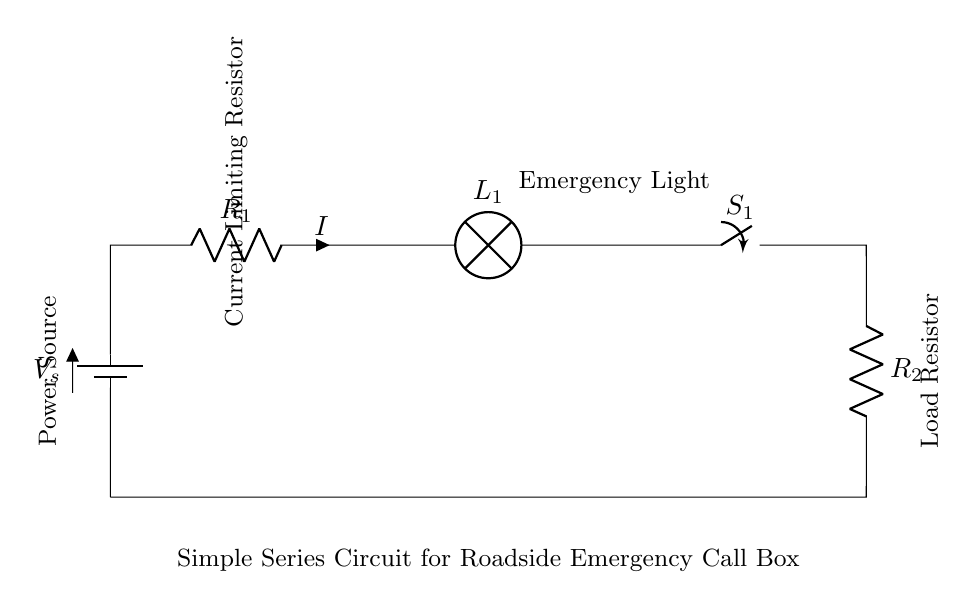What is the voltage source in this circuit? The voltage source in this circuit is represented by the symbol for the battery, indicating that there is a potential difference provided to the circuit.
Answer: V_s What type of light does this circuit use? The circuit includes a lamp, which is typically an emergency light in this context, indicating it will illuminate when the circuit is active.
Answer: Emergency Light How many resistors are present in this circuit? There are two resistors shown in the circuit, one labeled as R1 and the other as R2, which are both part of the series connection.
Answer: 2 What happens to the current if one component fails? In a series circuit, if one component fails (like a resistor or the lamp), the entire circuit is interrupted, leading to no current flow.
Answer: No current What is the purpose of R1 in this circuit? R1 serves as a current-limiting resistor, protecting the lamp from excessive current that could damage it, thus ensuring safe operation.
Answer: Current Limiting Resistor 